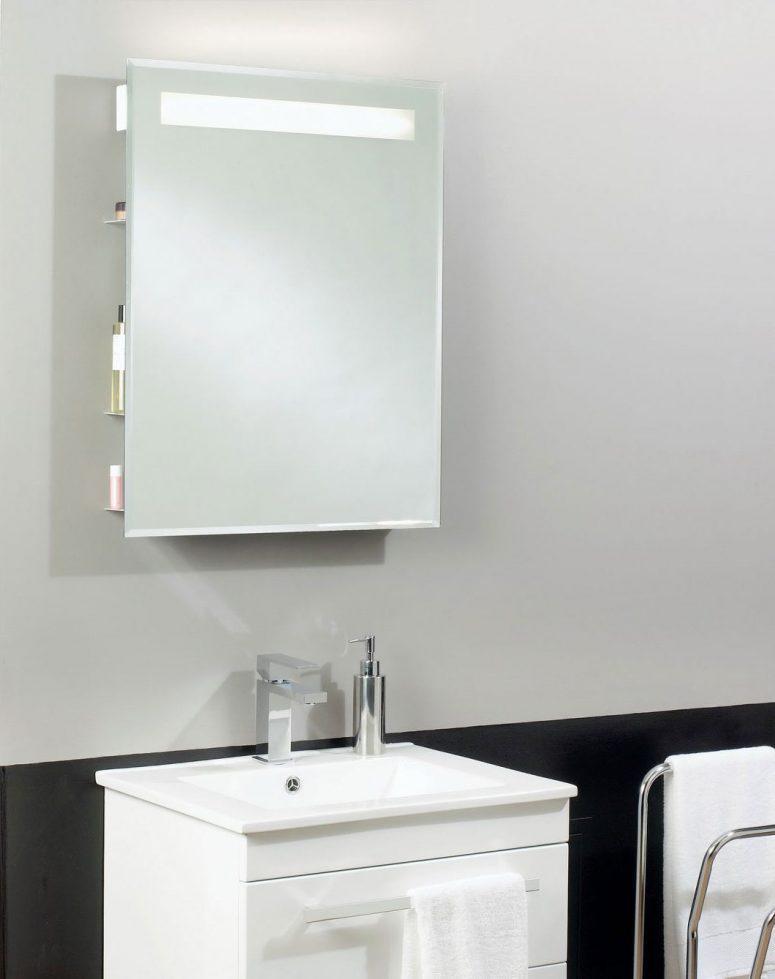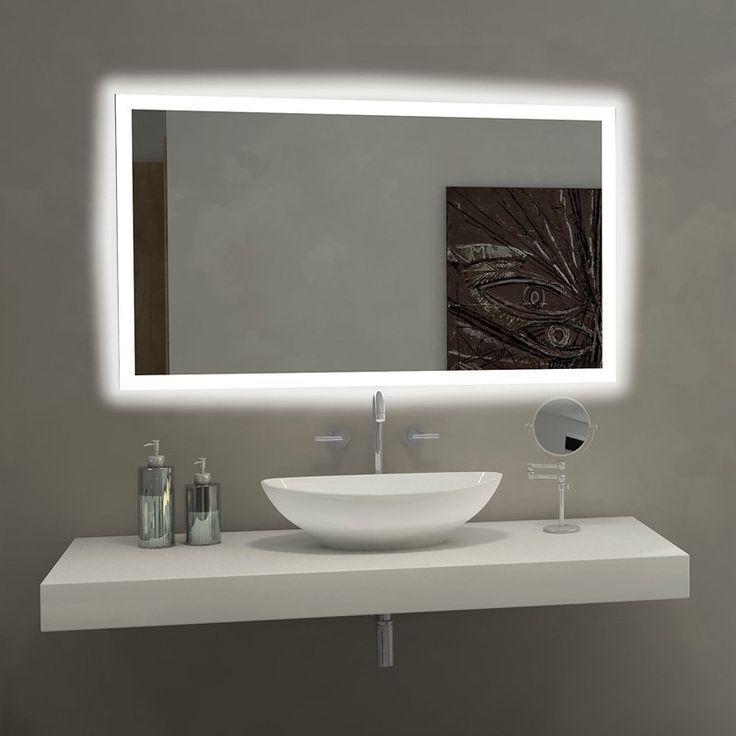The first image is the image on the left, the second image is the image on the right. For the images displayed, is the sentence "In one image, a wide footed vanity has two matching sinks mounted on top of the vanity and a one large mirror on the wall behind it." factually correct? Answer yes or no. No. The first image is the image on the left, the second image is the image on the right. Given the left and right images, does the statement "An image shows a vanity with side-by-side sinks that rest atop the counter." hold true? Answer yes or no. No. 